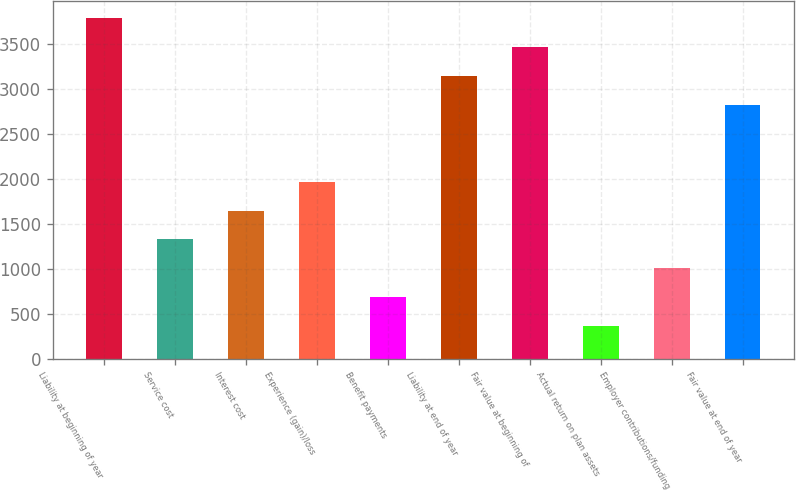<chart> <loc_0><loc_0><loc_500><loc_500><bar_chart><fcel>Liability at beginning of year<fcel>Service cost<fcel>Interest cost<fcel>Experience (gain)/loss<fcel>Benefit payments<fcel>Liability at end of year<fcel>Fair value at beginning of<fcel>Actual return on plan assets<fcel>Employer contributions/funding<fcel>Fair value at end of year<nl><fcel>3782.4<fcel>1328.2<fcel>1648<fcel>1967.8<fcel>688.6<fcel>3142.8<fcel>3462.6<fcel>368.8<fcel>1008.4<fcel>2823<nl></chart> 